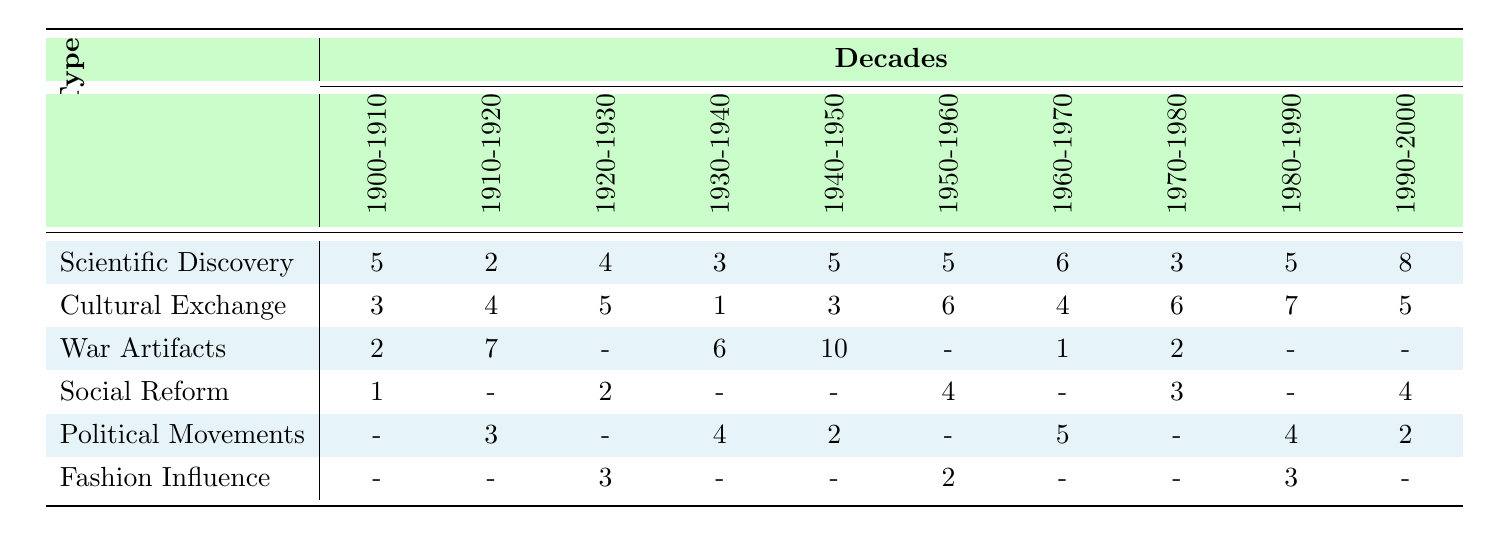What decade saw the highest number of War Artifacts acquired? Looking at the row for War Artifacts, the values across the decades show that 10 artifacts were acquired during the decade of 1940-1950, which is the highest amongst all decades.
Answer: 1940-1950 How many Scientific Discovery artifacts were acquired in the 1920-1930 decade? The table indicates that 4 Scientific Discovery artifacts were acquired in the 1920-1930 decade.
Answer: 4 What is the total number of Cultural Exchange artifacts acquired from 1900-2000? To find the total, we sum the values from the Cultural Exchange row for all decades: 3 + 4 + 5 + 1 + 3 + 6 + 4 + 6 + 7 + 5 = 44.
Answer: 44 Did Social Reform artifacts ever exceed 4 in any decade? Checking the Social Reform row, the maximum value is 4, which occurs in the decade of 1950-1960. This means it does exceed 4 artifacts only in that decade but does not exceed it in any other decade.
Answer: Yes What type of event had the least number of artifacts acquired in the decade of 1930-1940? In the decade of 1930-1940, the row for Cultural Exchange shows only 1 artifact acquired. Looking at other types of events in this decade, War Artifacts had 6, Political Movements had 4, and Scientific Discovery had 3. So Cultural Exchange had the least.
Answer: Cultural Exchange What was the average number of Political Movement artifacts acquired per decade from 1900-2000? The values for Political Movements are: 0 (1900-1910), 3 (1910-1920), 0 (1920-1930), 4 (1930-1940), 2 (1940-1950), 0 (1950-1960), 5 (1960-1970), 0 (1970-1980), 4 (1980-1990), 2 (1990-2000). Summing these, we get 0 + 3 + 0 + 4 + 2 + 0 + 5 + 0 + 4 + 2 = 20. There are 10 decades, so the average is 20 / 10 = 2.
Answer: 2 Which decade had more Scientific Discovery artifacts acquired, 1950-1960 or 1960-1970? In the 1950-1960 decade, 5 Scientific Discovery artifacts were acquired, while in the 1960-1970 decade, 6 artifacts were acquired. Comparing the two values, 6 is greater than 5, indicating that there were more artifacts in the 1960-1970 decade.
Answer: 1960-1970 What is the difference in the number of Cultural Exchange artifacts acquired between the decades 1980-1990 and 1940-1950? The values from the table show 7 Cultural Exchange artifacts acquired in 1980-1990 and 3 in 1940-1950. To find the difference, we subtract 3 from 7, resulting in 4.
Answer: 4 